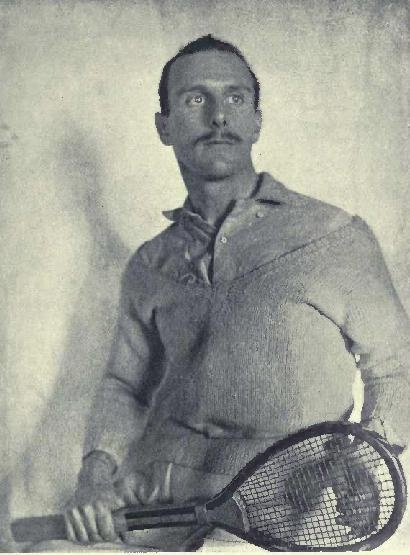Describe the objects in this image and their specific colors. I can see people in gray, darkgray, and black tones and tennis racket in gray, darkgray, black, and lightgray tones in this image. 